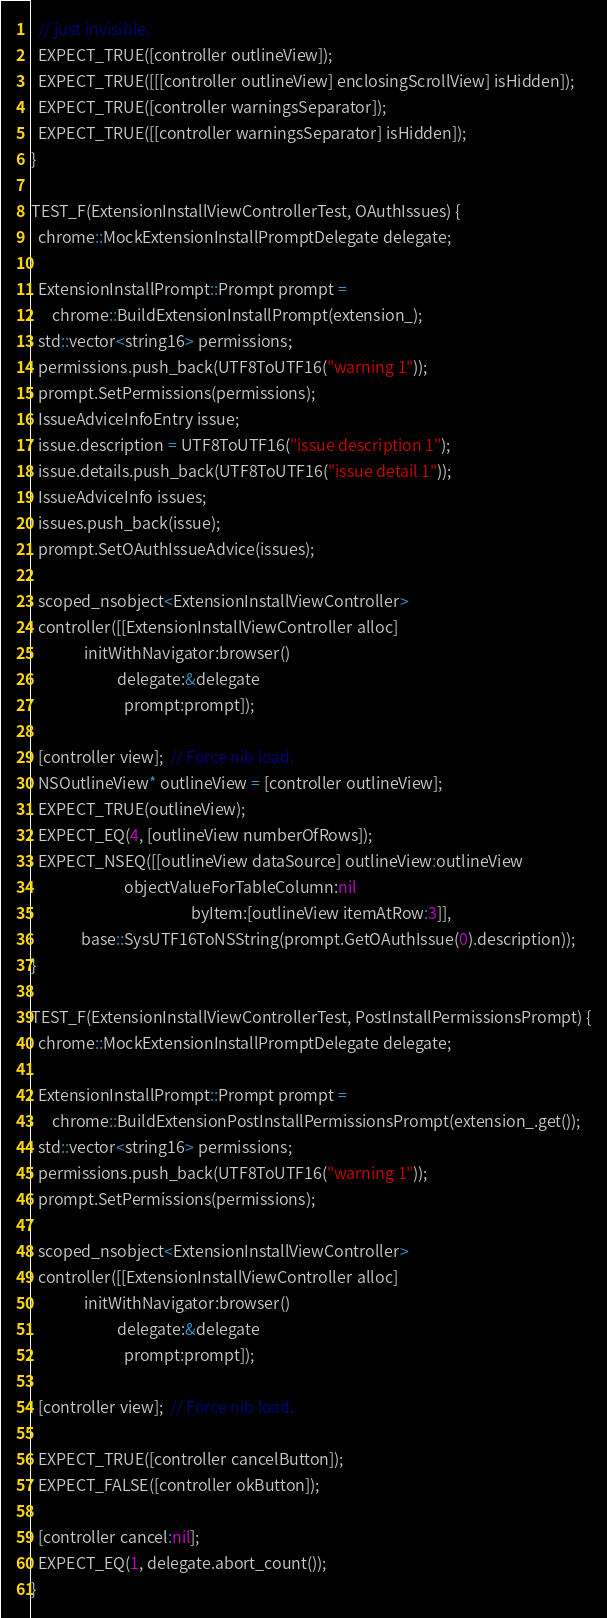<code> <loc_0><loc_0><loc_500><loc_500><_ObjectiveC_>  // just invisible.
  EXPECT_TRUE([controller outlineView]);
  EXPECT_TRUE([[[controller outlineView] enclosingScrollView] isHidden]);
  EXPECT_TRUE([controller warningsSeparator]);
  EXPECT_TRUE([[controller warningsSeparator] isHidden]);
}

TEST_F(ExtensionInstallViewControllerTest, OAuthIssues) {
  chrome::MockExtensionInstallPromptDelegate delegate;

  ExtensionInstallPrompt::Prompt prompt =
      chrome::BuildExtensionInstallPrompt(extension_);
  std::vector<string16> permissions;
  permissions.push_back(UTF8ToUTF16("warning 1"));
  prompt.SetPermissions(permissions);
  IssueAdviceInfoEntry issue;
  issue.description = UTF8ToUTF16("issue description 1");
  issue.details.push_back(UTF8ToUTF16("issue detail 1"));
  IssueAdviceInfo issues;
  issues.push_back(issue);
  prompt.SetOAuthIssueAdvice(issues);

  scoped_nsobject<ExtensionInstallViewController>
  controller([[ExtensionInstallViewController alloc]
               initWithNavigator:browser()
                        delegate:&delegate
                          prompt:prompt]);

  [controller view];  // Force nib load.
  NSOutlineView* outlineView = [controller outlineView];
  EXPECT_TRUE(outlineView);
  EXPECT_EQ(4, [outlineView numberOfRows]);
  EXPECT_NSEQ([[outlineView dataSource] outlineView:outlineView
                          objectValueForTableColumn:nil
                                             byItem:[outlineView itemAtRow:3]],
              base::SysUTF16ToNSString(prompt.GetOAuthIssue(0).description));
}

TEST_F(ExtensionInstallViewControllerTest, PostInstallPermissionsPrompt) {
  chrome::MockExtensionInstallPromptDelegate delegate;

  ExtensionInstallPrompt::Prompt prompt =
      chrome::BuildExtensionPostInstallPermissionsPrompt(extension_.get());
  std::vector<string16> permissions;
  permissions.push_back(UTF8ToUTF16("warning 1"));
  prompt.SetPermissions(permissions);

  scoped_nsobject<ExtensionInstallViewController>
  controller([[ExtensionInstallViewController alloc]
               initWithNavigator:browser()
                        delegate:&delegate
                          prompt:prompt]);

  [controller view];  // Force nib load.

  EXPECT_TRUE([controller cancelButton]);
  EXPECT_FALSE([controller okButton]);

  [controller cancel:nil];
  EXPECT_EQ(1, delegate.abort_count());
}
</code> 